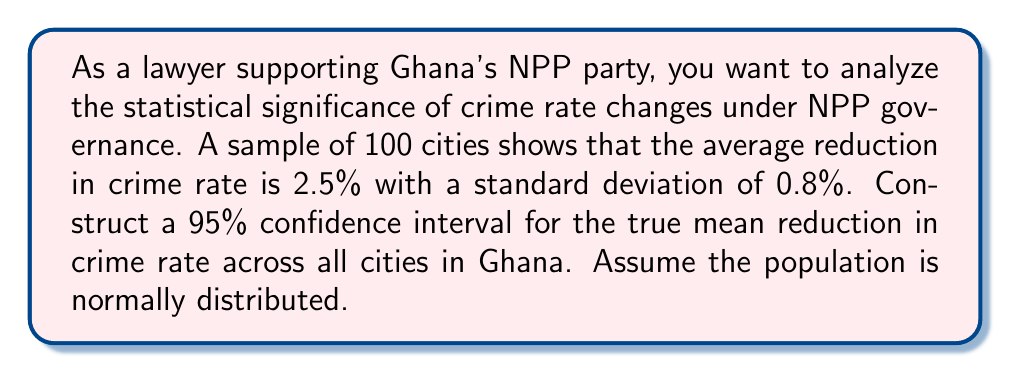Can you solve this math problem? Let's approach this step-by-step:

1) We are given:
   - Sample size: $n = 100$
   - Sample mean: $\bar{x} = 2.5\%$
   - Sample standard deviation: $s = 0.8\%$
   - Confidence level: 95%

2) For a 95% confidence interval, we use a z-score of 1.96 (assuming normal distribution).

3) The formula for a confidence interval is:

   $$\bar{x} \pm z \cdot \frac{s}{\sqrt{n}}$$

4) Let's calculate the standard error:
   
   $$SE = \frac{s}{\sqrt{n}} = \frac{0.8}{\sqrt{100}} = \frac{0.8}{10} = 0.08$$

5) Now, let's calculate the margin of error:

   $$ME = z \cdot SE = 1.96 \cdot 0.08 = 0.1568$$

6) Finally, we can construct the confidence interval:

   Lower bound: $2.5 - 0.1568 = 2.3432\%$
   Upper bound: $2.5 + 0.1568 = 2.6568\%$

7) Therefore, we are 95% confident that the true mean reduction in crime rate across all cities in Ghana is between 2.3432% and 2.6568%.
Answer: (2.3432%, 2.6568%) 